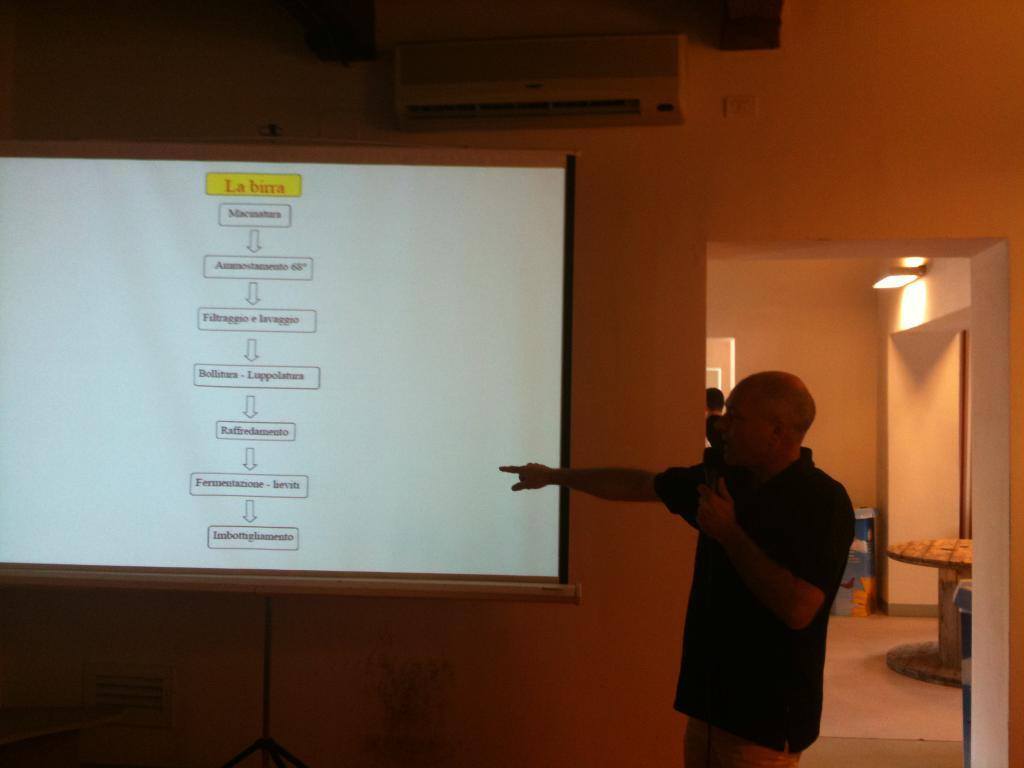<image>
Offer a succinct explanation of the picture presented. A flow chart on a screen has "La birra" at the top. 